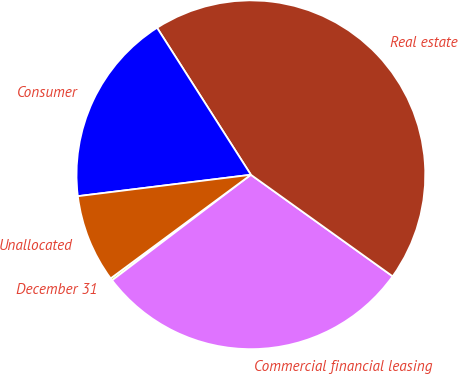Convert chart. <chart><loc_0><loc_0><loc_500><loc_500><pie_chart><fcel>December 31<fcel>Commercial financial leasing<fcel>Real estate<fcel>Consumer<fcel>Unallocated<nl><fcel>0.22%<fcel>29.76%<fcel>43.94%<fcel>17.92%<fcel>8.17%<nl></chart> 